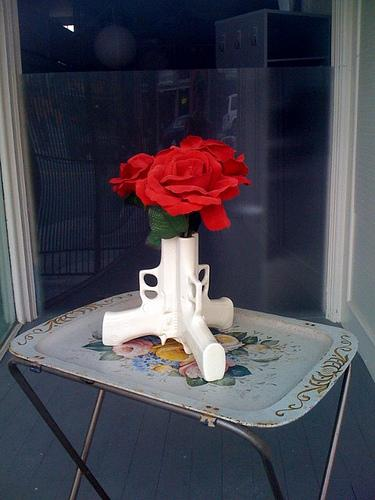Describe the flooring in the image. The flooring is blue wooden, made from different types of wood. Mention the number of petals and leaves visible in the image. There are 10 red petals and 1 set of green leaves. Explain the style and material of the stand where the flowers are placed. The stand is a white ceramic stand with three X-type iron legs and a grey color on the legs. Assess the quality of the image in terms of object clarity and arrangement. The image quality is high with clear object boundaries, well-defined coordinates, and an aesthetically pleasing arrangement. What type of reasoning is required to understand the connection between the vase and the flowers? Complex reasoning is needed to understand the unconventional choice of a gun vase to hold red flowers. What does the tray holding the vase look like? The tray has a gold border, a flower image, rusty edges, and grey legs. Provide some information about the background elements of the image. There is a window with a white frame, a globe light, and the shadows of other products are visible. Analyze the sentiment or emotion conveyed through this image. The image conveys a creative and intriguing sentiment due to the unique gun vase and artistic arrangement of flowers. What unique feature can be found on the vase holding the red flowers? The vase has a white gun design. Can you spot the blue butterfly sitting on the edge of the vase? There is no blue butterfly visible in the image. Examine the lush green ferns sprouting from the vase, accompanying the red flowers. There are no green ferns visible in the image; only red flowers and green leaves are present. Do you see the string of pearls draped around the gun vase, adding an elegant touch? There is no string of pearls visible in the image. Look for a small yellow bird perched on one of the green leaves, chirping happily. There is no yellow bird visible in the image. Can you identify the striped orange cat lounging in the window behind the vase? There is no cat visible in the image. Notice the tall, purple candle flickering atop the white ceramic stand. There is no candle visible in the image. 